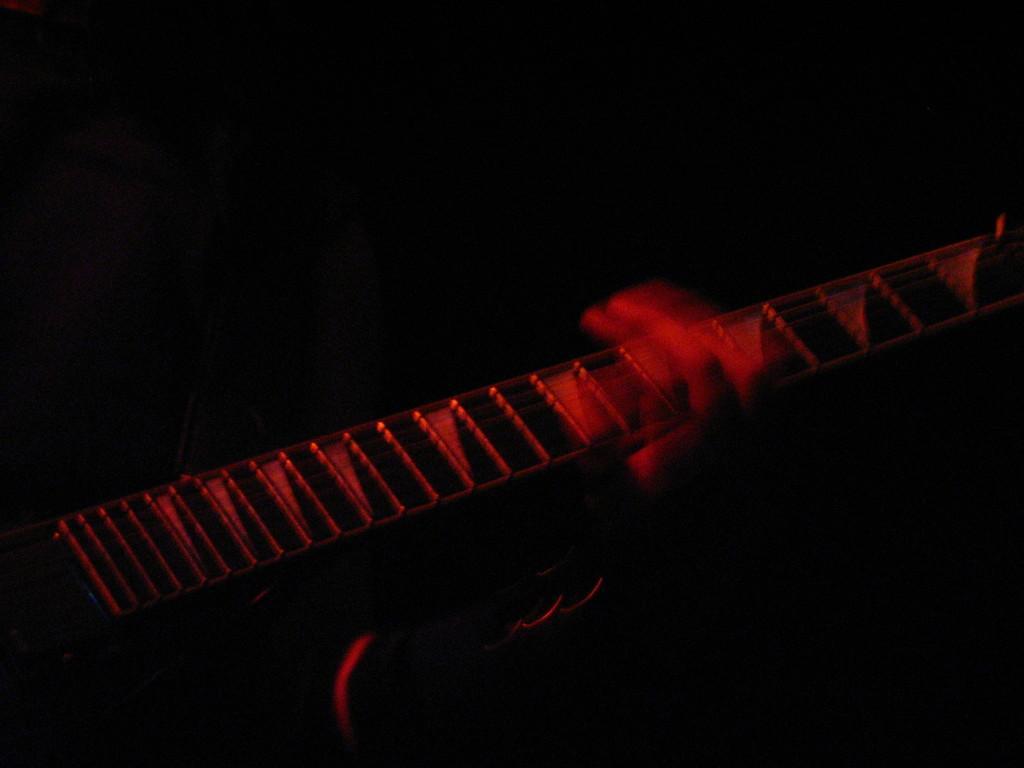In one or two sentences, can you explain what this image depicts? In this image I can see it looks like a person's hand. This person is holding the guitar and there is the dark background. 